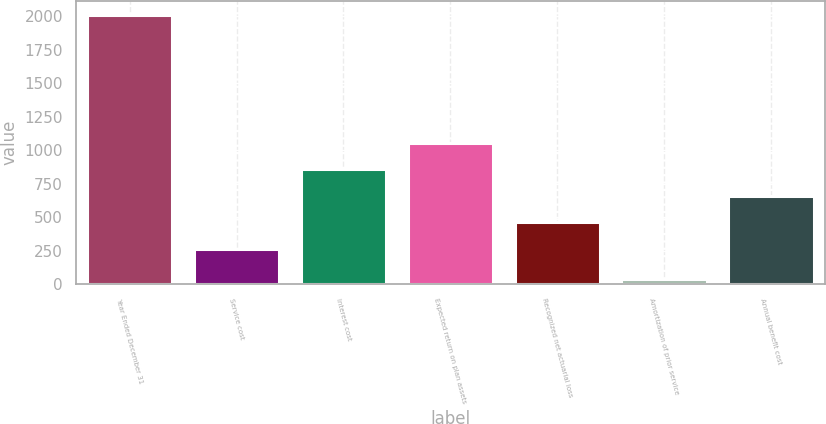Convert chart. <chart><loc_0><loc_0><loc_500><loc_500><bar_chart><fcel>Year Ended December 31<fcel>Service cost<fcel>Interest cost<fcel>Expected return on plan assets<fcel>Recognized net actuarial loss<fcel>Amortization of prior service<fcel>Annual benefit cost<nl><fcel>2012<fcel>266<fcel>857<fcel>1054<fcel>463<fcel>42<fcel>660<nl></chart> 